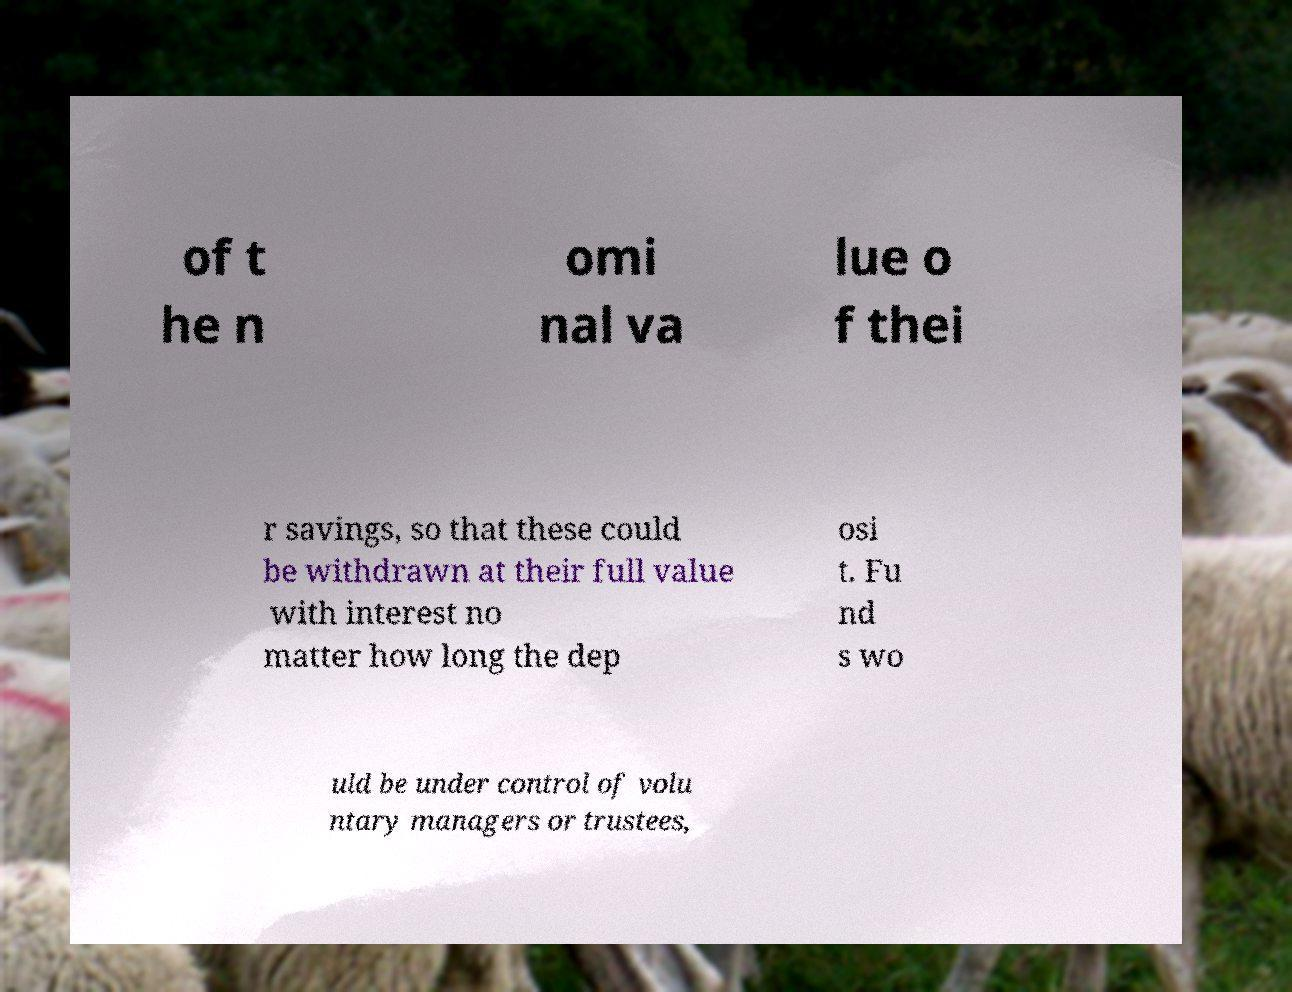There's text embedded in this image that I need extracted. Can you transcribe it verbatim? of t he n omi nal va lue o f thei r savings, so that these could be withdrawn at their full value with interest no matter how long the dep osi t. Fu nd s wo uld be under control of volu ntary managers or trustees, 